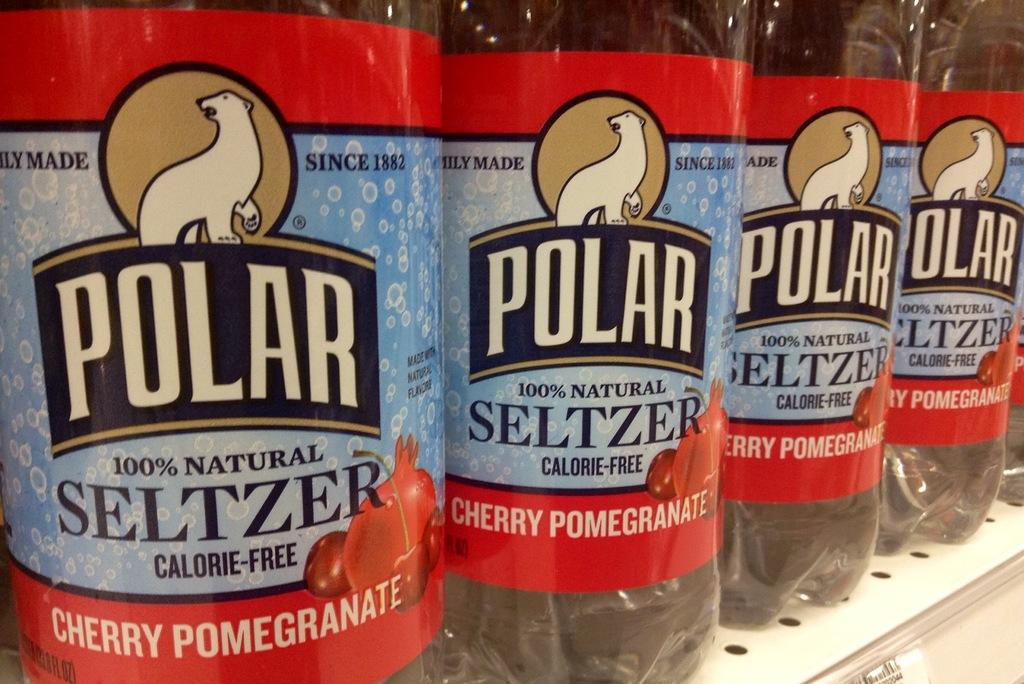Provide a one-sentence caption for the provided image. A close up of the labels of four identical Polar Cherry Pomegranite flavoured Selzer bottles. 